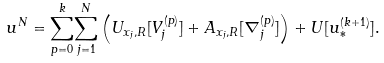Convert formula to latex. <formula><loc_0><loc_0><loc_500><loc_500>u ^ { N } = \underset { p = 0 } { \overset { k } { \sum } } \underset { j = 1 } { \overset { N } { \sum } } \left ( U _ { x _ { j } , R } [ V _ { j } ^ { ( p ) } ] + A _ { x _ { j } , R } [ \nabla _ { j } ^ { ( p ) } ] \right ) + U [ u _ { * } ^ { ( k + 1 ) } ] .</formula> 